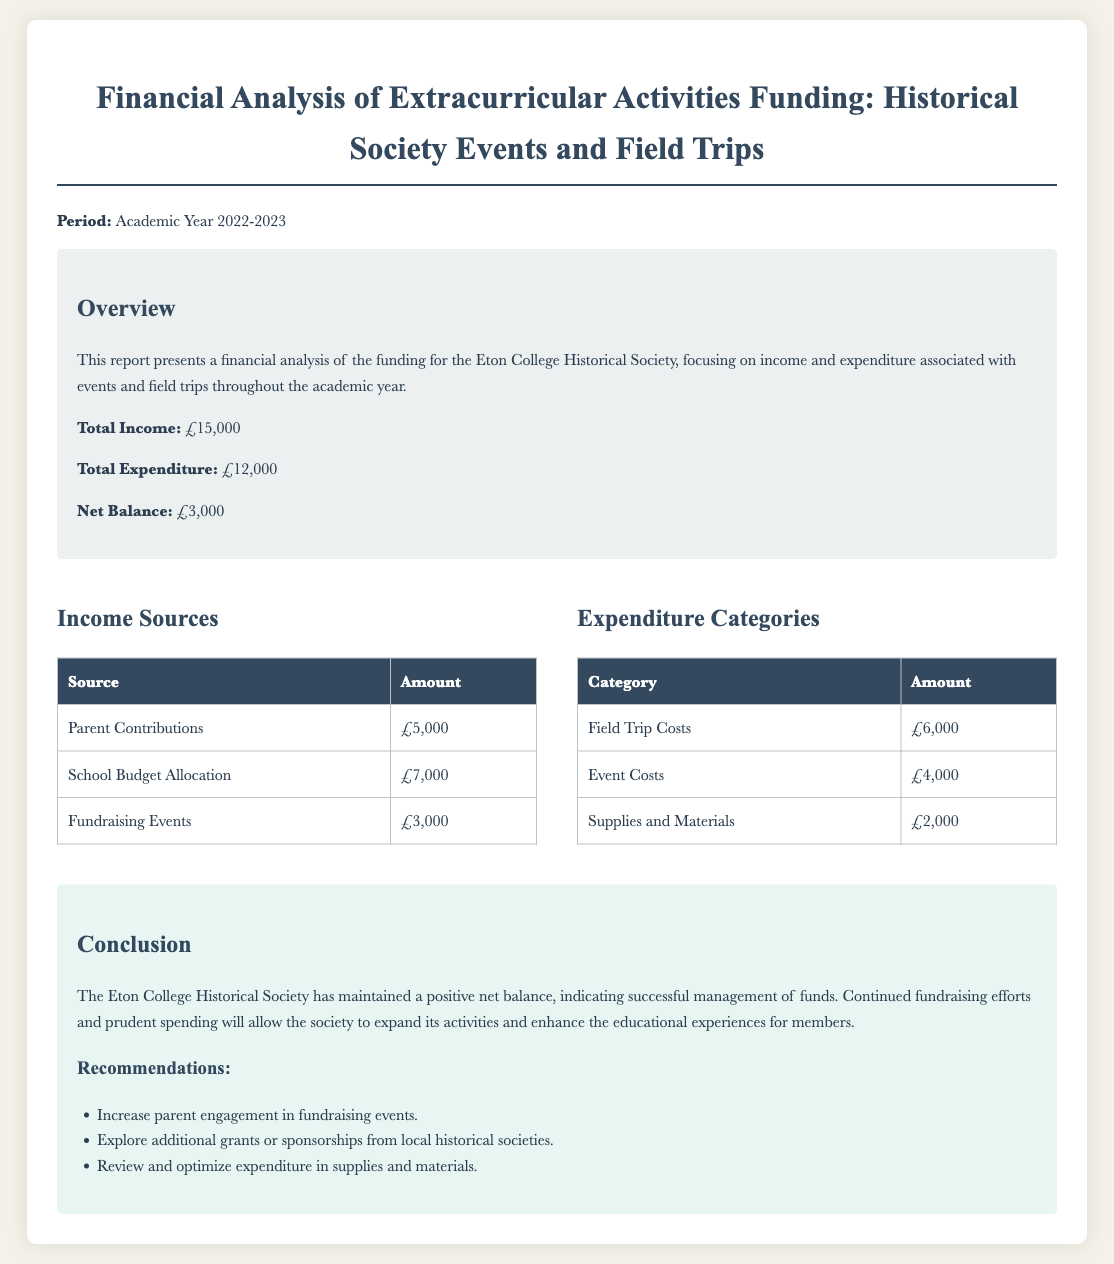What is the total income? The total income is explicitly stated in the overview section of the document, which is £15,000.
Answer: £15,000 What is the total expenditure? The total expenditure is also provided in the overview section, which amounts to £12,000.
Answer: £12,000 What is the net balance? The net balance is calculated as total income minus total expenditure, which is mentioned as £3,000 in the document.
Answer: £3,000 What is the amount from parent contributions? The specific amount contributed by parents is listed directly in the income sources table, which is £5,000.
Answer: £5,000 What are the field trip costs? The cost specifically allocated for field trips is detailed in the expenditure categories table, which is £6,000.
Answer: £6,000 How much was raised from fundraising events? The total amount raised through fundraising events is stated in the income sources, which is £3,000.
Answer: £3,000 What is one recommendation from the conclusion? One of the recommendations stated in the conclusion suggests increasing parent engagement in fundraising events.
Answer: Increase parent engagement in fundraising events Which category had the highest expenditure? The category with the highest expenditure is indicated in the expenditure categories table, which is field trip costs.
Answer: Field Trip Costs What percentage of total income was spent on event costs? To calculate this percentage, event costs (£4,000) are divided by total income (£15,000) and then multiplied by 100, which yields approximately 26.67%.
Answer: 26.67% What is the style of the document? The document uses a serif font for body text, specifically 'Baskerville' as mentioned in the style section.
Answer: Baskerville 